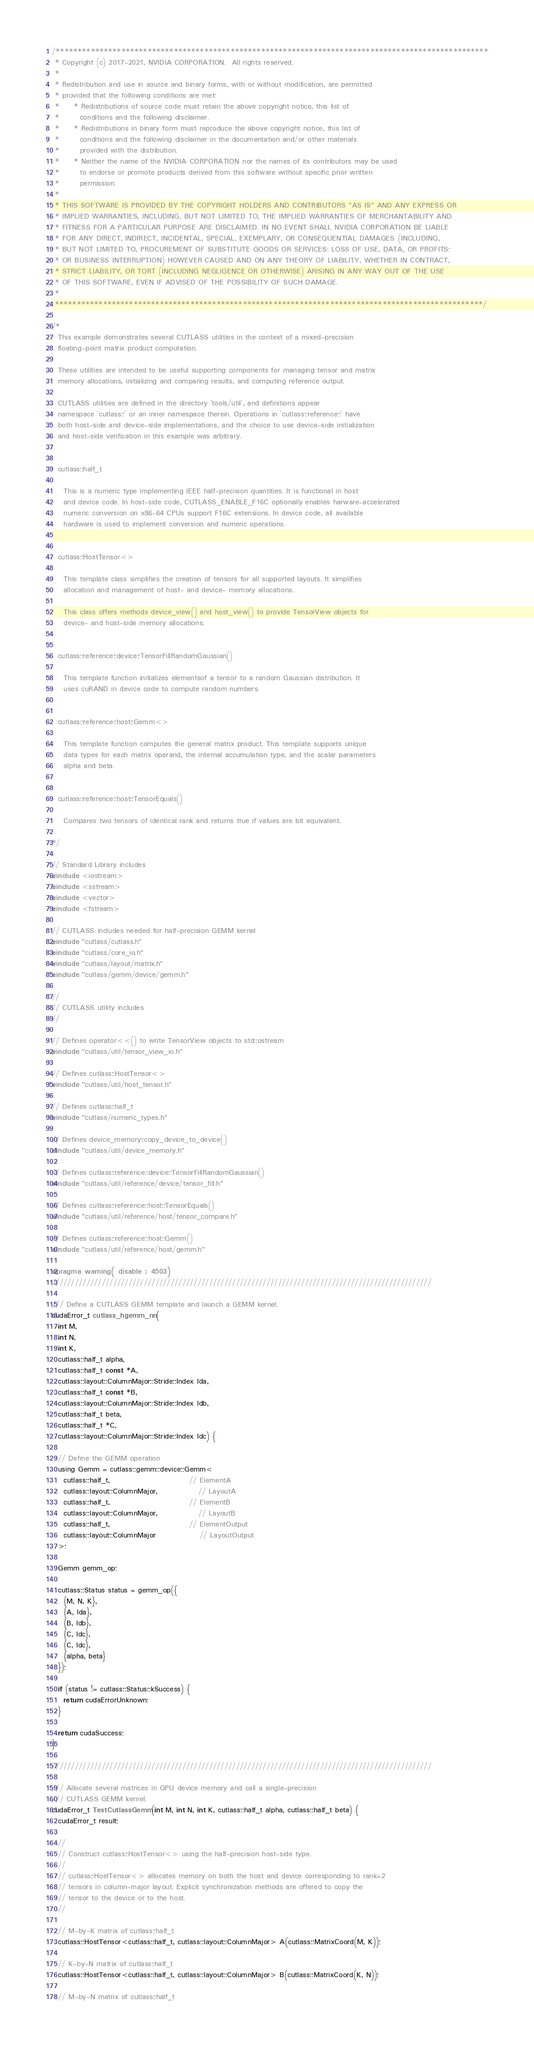Convert code to text. <code><loc_0><loc_0><loc_500><loc_500><_Cuda_>/***************************************************************************************************
 * Copyright (c) 2017-2021, NVIDIA CORPORATION.  All rights reserved.
 *
 * Redistribution and use in source and binary forms, with or without modification, are permitted
 * provided that the following conditions are met:
 *     * Redistributions of source code must retain the above copyright notice, this list of
 *       conditions and the following disclaimer.
 *     * Redistributions in binary form must reproduce the above copyright notice, this list of
 *       conditions and the following disclaimer in the documentation and/or other materials
 *       provided with the distribution.
 *     * Neither the name of the NVIDIA CORPORATION nor the names of its contributors may be used
 *       to endorse or promote products derived from this software without specific prior written
 *       permission.
 *
 * THIS SOFTWARE IS PROVIDED BY THE COPYRIGHT HOLDERS AND CONTRIBUTORS "AS IS" AND ANY EXPRESS OR
 * IMPLIED WARRANTIES, INCLUDING, BUT NOT LIMITED TO, THE IMPLIED WARRANTIES OF MERCHANTABILITY AND
 * FITNESS FOR A PARTICULAR PURPOSE ARE DISCLAIMED. IN NO EVENT SHALL NVIDIA CORPORATION BE LIABLE
 * FOR ANY DIRECT, INDIRECT, INCIDENTAL, SPECIAL, EXEMPLARY, OR CONSEQUENTIAL DAMAGES (INCLUDING,
 * BUT NOT LIMITED TO, PROCUREMENT OF SUBSTITUTE GOODS OR SERVICES; LOSS OF USE, DATA, OR PROFITS;
 * OR BUSINESS INTERRUPTION) HOWEVER CAUSED AND ON ANY THEORY OF LIABILITY, WHETHER IN CONTRACT,
 * STRICT LIABILITY, OR TORT (INCLUDING NEGLIGENCE OR OTHERWISE) ARISING IN ANY WAY OUT OF THE USE
 * OF THIS SOFTWARE, EVEN IF ADVISED OF THE POSSIBILITY OF SUCH DAMAGE.
 *
 **************************************************************************************************/

/*
  This example demonstrates several CUTLASS utilities in the context of a mixed-precision
  floating-point matrix product computation.

  These utilities are intended to be useful supporting components for managing tensor and matrix
  memory allocations, initializing and comparing results, and computing reference output.

  CUTLASS utilities are defined in the directory `tools/util`, and definitions appear
  namespace `cutlass::` or an inner namespace therein. Operations in `cutlass::reference::` have
  both host-side and device-side implementations, and the choice to use device-side initialization
  and host-side verification in this example was arbitrary.


  cutlass::half_t

    This is a numeric type implementing IEEE half-precision quantities. It is functional in host
    and device code. In host-side code, CUTLASS_ENABLE_F16C optionally enables harware-accelerated
    numeric conversion on x86-64 CPUs support F16C extensions. In device code, all available
    hardware is used to implement conversion and numeric operations.


  cutlass::HostTensor<>

    This template class simplifies the creation of tensors for all supported layouts. It simplifies
    allocation and management of host- and device- memory allocations.

    This class offers methods device_view() and host_view() to provide TensorView objects for
    device- and host-side memory allocations.


  cutlass::reference::device::TensorFillRandomGaussian()

    This template function initializes elementsof a tensor to a random Gaussian distribution. It
    uses cuRAND in device code to compute random numbers.


  cutlass::reference::host::Gemm<>

    This template function computes the general matrix product. This template supports unique
    data types for each matrix operand, the internal accumulation type, and the scalar parameters
    alpha and beta.


  cutlass::reference::host::TensorEquals()

    Compares two tensors of identical rank and returns true if values are bit equivalent.

*/

// Standard Library includes
#include <iostream>
#include <sstream>
#include <vector>
#include <fstream>

// CUTLASS includes needed for half-precision GEMM kernel
#include "cutlass/cutlass.h"
#include "cutlass/core_io.h"
#include "cutlass/layout/matrix.h"
#include "cutlass/gemm/device/gemm.h"

//
// CUTLASS utility includes
//

// Defines operator<<() to write TensorView objects to std::ostream
#include "cutlass/util/tensor_view_io.h"

// Defines cutlass::HostTensor<>
#include "cutlass/util/host_tensor.h"

// Defines cutlass::half_t
#include "cutlass/numeric_types.h"

// Defines device_memory::copy_device_to_device()
#include "cutlass/util/device_memory.h"

// Defines cutlass::reference::device::TensorFillRandomGaussian()
#include "cutlass/util/reference/device/tensor_fill.h"

// Defines cutlass::reference::host::TensorEquals()
#include "cutlass/util/reference/host/tensor_compare.h"

// Defines cutlass::reference::host::Gemm()
#include "cutlass/util/reference/host/gemm.h"

#pragma warning( disable : 4503)
///////////////////////////////////////////////////////////////////////////////////////////////////

/// Define a CUTLASS GEMM template and launch a GEMM kernel.
cudaError_t cutlass_hgemm_nn(
  int M,
  int N,
  int K,
  cutlass::half_t alpha,
  cutlass::half_t const *A,
  cutlass::layout::ColumnMajor::Stride::Index lda,
  cutlass::half_t const *B,
  cutlass::layout::ColumnMajor::Stride::Index ldb,
  cutlass::half_t beta,
  cutlass::half_t *C,
  cutlass::layout::ColumnMajor::Stride::Index ldc) {

  // Define the GEMM operation
  using Gemm = cutlass::gemm::device::Gemm<
    cutlass::half_t,                           // ElementA
    cutlass::layout::ColumnMajor,              // LayoutA
    cutlass::half_t,                           // ElementB
    cutlass::layout::ColumnMajor,              // LayoutB
    cutlass::half_t,                           // ElementOutput
    cutlass::layout::ColumnMajor               // LayoutOutput
  >;

  Gemm gemm_op;
  
  cutlass::Status status = gemm_op({
    {M, N, K},
    {A, lda},
    {B, ldb},
    {C, ldc},
    {C, ldc},
    {alpha, beta}
  });

  if (status != cutlass::Status::kSuccess) {
    return cudaErrorUnknown;
  }

  return cudaSuccess;
}

///////////////////////////////////////////////////////////////////////////////////////////////////

/// Allocate several matrices in GPU device memory and call a single-precision
/// CUTLASS GEMM kernel.
cudaError_t TestCutlassGemm(int M, int N, int K, cutlass::half_t alpha, cutlass::half_t beta) {
  cudaError_t result;

  //
  // Construct cutlass::HostTensor<> using the half-precision host-side type.
  //
  // cutlass::HostTensor<> allocates memory on both the host and device corresponding to rank=2
  // tensors in column-major layout. Explicit synchronization methods are offered to copy the
  // tensor to the device or to the host.
  //

  // M-by-K matrix of cutlass::half_t
  cutlass::HostTensor<cutlass::half_t, cutlass::layout::ColumnMajor> A(cutlass::MatrixCoord(M, K));

  // K-by-N matrix of cutlass::half_t
  cutlass::HostTensor<cutlass::half_t, cutlass::layout::ColumnMajor> B(cutlass::MatrixCoord(K, N));

  // M-by-N matrix of cutlass::half_t</code> 